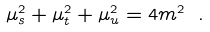<formula> <loc_0><loc_0><loc_500><loc_500>\mu _ { s } ^ { 2 } + \mu _ { t } ^ { 2 } + \mu _ { u } ^ { 2 } = 4 m ^ { 2 } \ .</formula> 